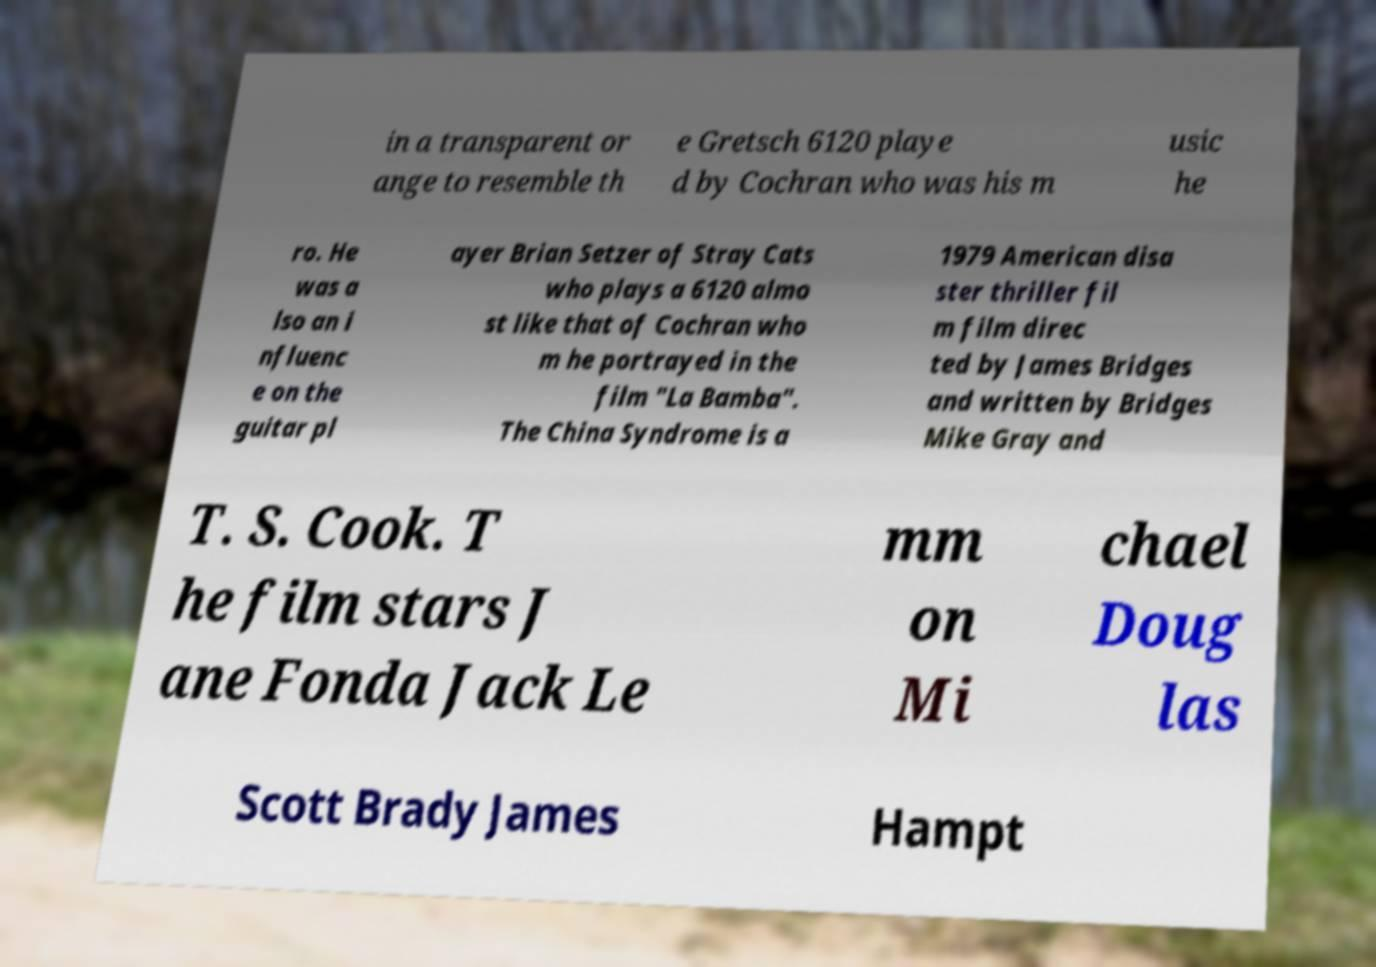For documentation purposes, I need the text within this image transcribed. Could you provide that? in a transparent or ange to resemble th e Gretsch 6120 playe d by Cochran who was his m usic he ro. He was a lso an i nfluenc e on the guitar pl ayer Brian Setzer of Stray Cats who plays a 6120 almo st like that of Cochran who m he portrayed in the film "La Bamba". The China Syndrome is a 1979 American disa ster thriller fil m film direc ted by James Bridges and written by Bridges Mike Gray and T. S. Cook. T he film stars J ane Fonda Jack Le mm on Mi chael Doug las Scott Brady James Hampt 